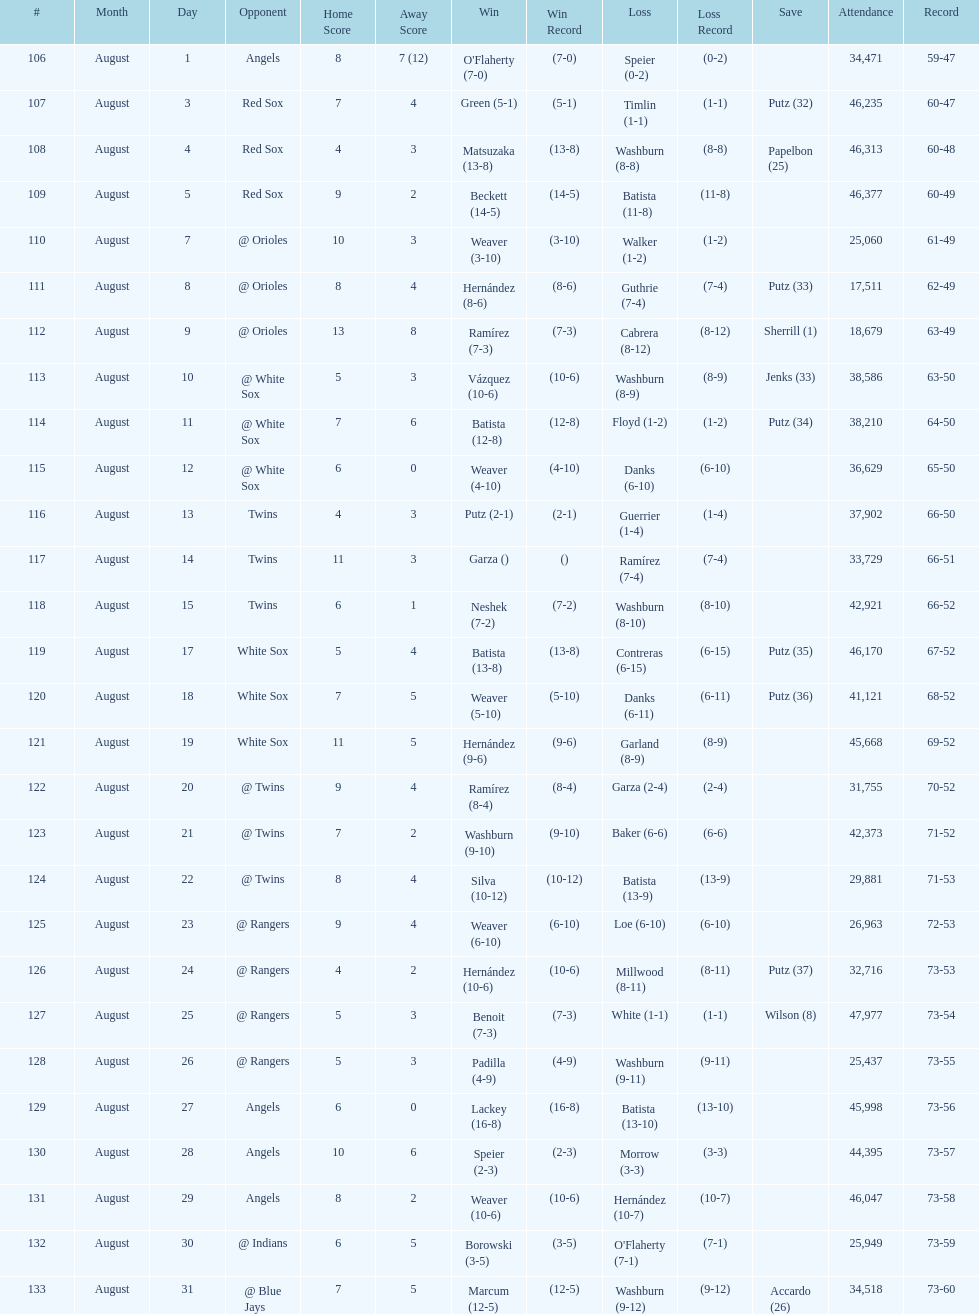How many losses during stretch? 7. 